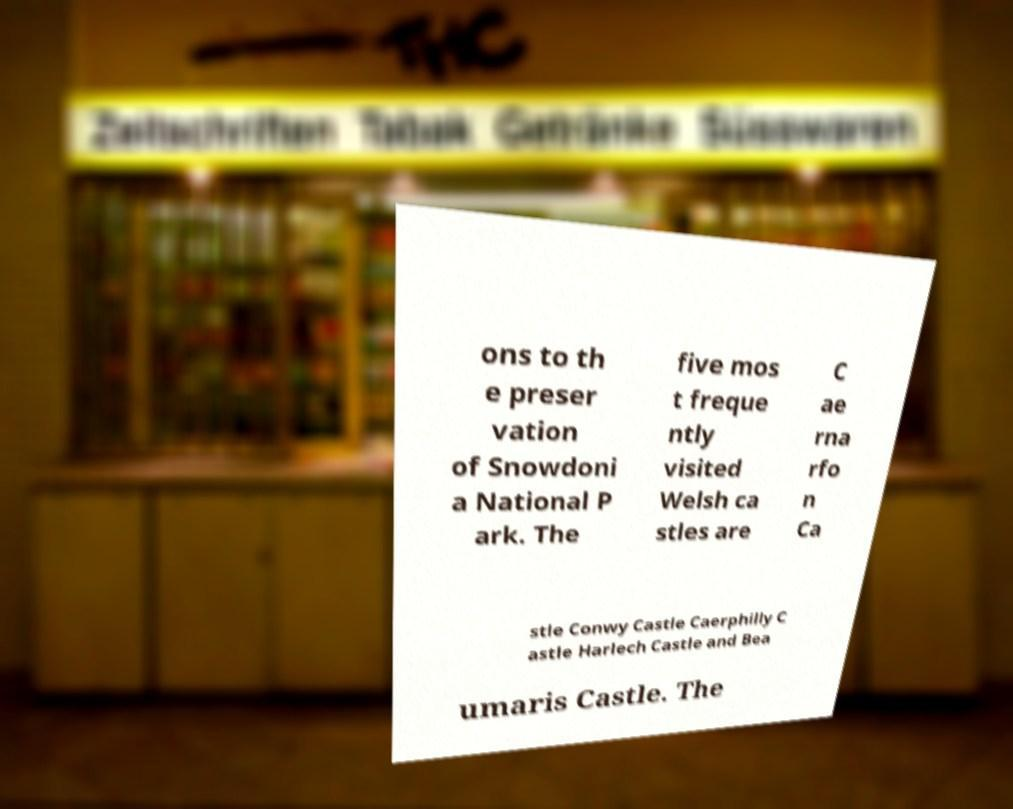Please identify and transcribe the text found in this image. ons to th e preser vation of Snowdoni a National P ark. The five mos t freque ntly visited Welsh ca stles are C ae rna rfo n Ca stle Conwy Castle Caerphilly C astle Harlech Castle and Bea umaris Castle. The 